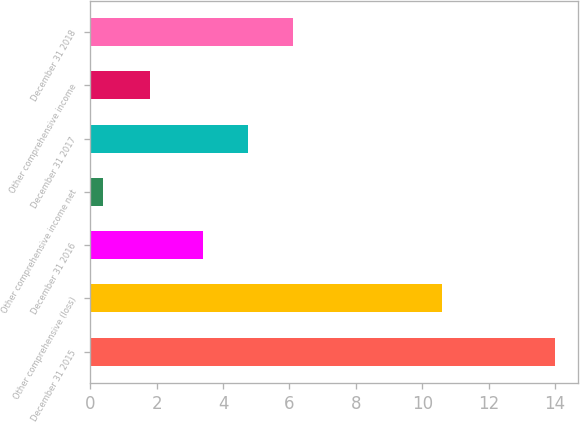Convert chart. <chart><loc_0><loc_0><loc_500><loc_500><bar_chart><fcel>December 31 2015<fcel>Other comprehensive (loss)<fcel>December 31 2016<fcel>Other comprehensive income net<fcel>December 31 2017<fcel>Other comprehensive income<fcel>December 31 2018<nl><fcel>14<fcel>10.6<fcel>3.4<fcel>0.4<fcel>4.76<fcel>1.8<fcel>6.12<nl></chart> 